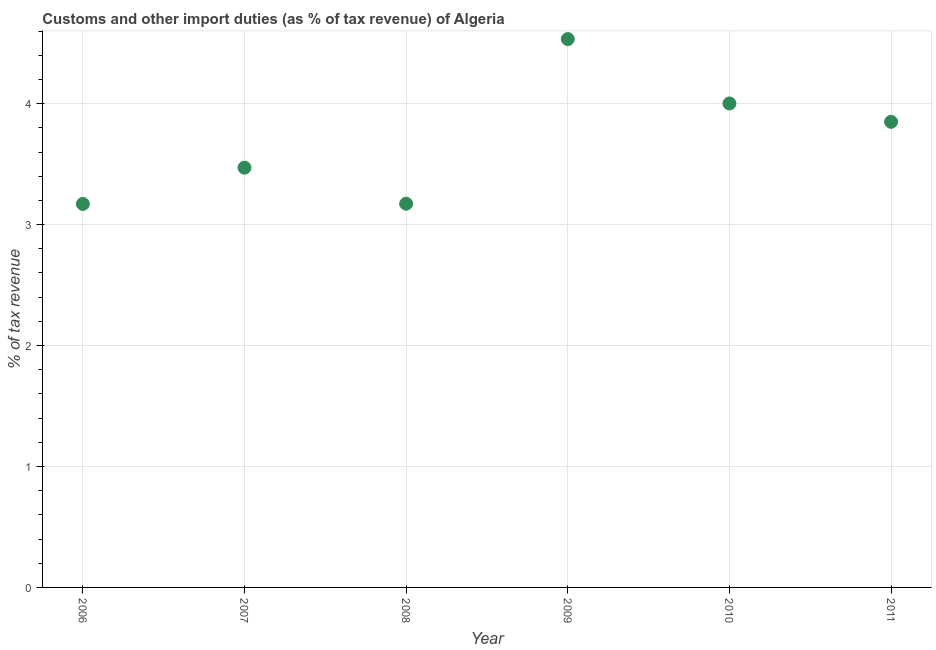What is the customs and other import duties in 2006?
Give a very brief answer. 3.17. Across all years, what is the maximum customs and other import duties?
Make the answer very short. 4.53. Across all years, what is the minimum customs and other import duties?
Keep it short and to the point. 3.17. What is the sum of the customs and other import duties?
Ensure brevity in your answer.  22.2. What is the difference between the customs and other import duties in 2006 and 2010?
Ensure brevity in your answer.  -0.83. What is the average customs and other import duties per year?
Make the answer very short. 3.7. What is the median customs and other import duties?
Your answer should be very brief. 3.66. In how many years, is the customs and other import duties greater than 3.2 %?
Provide a succinct answer. 4. Do a majority of the years between 2007 and 2011 (inclusive) have customs and other import duties greater than 0.6000000000000001 %?
Give a very brief answer. Yes. What is the ratio of the customs and other import duties in 2009 to that in 2011?
Make the answer very short. 1.18. Is the difference between the customs and other import duties in 2009 and 2010 greater than the difference between any two years?
Provide a succinct answer. No. What is the difference between the highest and the second highest customs and other import duties?
Provide a short and direct response. 0.53. What is the difference between the highest and the lowest customs and other import duties?
Keep it short and to the point. 1.36. In how many years, is the customs and other import duties greater than the average customs and other import duties taken over all years?
Keep it short and to the point. 3. How many dotlines are there?
Ensure brevity in your answer.  1. Are the values on the major ticks of Y-axis written in scientific E-notation?
Ensure brevity in your answer.  No. What is the title of the graph?
Provide a short and direct response. Customs and other import duties (as % of tax revenue) of Algeria. What is the label or title of the X-axis?
Make the answer very short. Year. What is the label or title of the Y-axis?
Make the answer very short. % of tax revenue. What is the % of tax revenue in 2006?
Your answer should be very brief. 3.17. What is the % of tax revenue in 2007?
Your response must be concise. 3.47. What is the % of tax revenue in 2008?
Your response must be concise. 3.17. What is the % of tax revenue in 2009?
Your response must be concise. 4.53. What is the % of tax revenue in 2010?
Your answer should be very brief. 4. What is the % of tax revenue in 2011?
Your response must be concise. 3.85. What is the difference between the % of tax revenue in 2006 and 2007?
Ensure brevity in your answer.  -0.3. What is the difference between the % of tax revenue in 2006 and 2008?
Give a very brief answer. -0. What is the difference between the % of tax revenue in 2006 and 2009?
Offer a terse response. -1.36. What is the difference between the % of tax revenue in 2006 and 2010?
Keep it short and to the point. -0.83. What is the difference between the % of tax revenue in 2006 and 2011?
Your response must be concise. -0.68. What is the difference between the % of tax revenue in 2007 and 2008?
Keep it short and to the point. 0.3. What is the difference between the % of tax revenue in 2007 and 2009?
Provide a short and direct response. -1.06. What is the difference between the % of tax revenue in 2007 and 2010?
Provide a succinct answer. -0.53. What is the difference between the % of tax revenue in 2007 and 2011?
Ensure brevity in your answer.  -0.38. What is the difference between the % of tax revenue in 2008 and 2009?
Provide a succinct answer. -1.36. What is the difference between the % of tax revenue in 2008 and 2010?
Offer a very short reply. -0.83. What is the difference between the % of tax revenue in 2008 and 2011?
Give a very brief answer. -0.68. What is the difference between the % of tax revenue in 2009 and 2010?
Your response must be concise. 0.53. What is the difference between the % of tax revenue in 2009 and 2011?
Ensure brevity in your answer.  0.68. What is the difference between the % of tax revenue in 2010 and 2011?
Provide a succinct answer. 0.15. What is the ratio of the % of tax revenue in 2006 to that in 2007?
Keep it short and to the point. 0.91. What is the ratio of the % of tax revenue in 2006 to that in 2008?
Ensure brevity in your answer.  1. What is the ratio of the % of tax revenue in 2006 to that in 2009?
Your answer should be compact. 0.7. What is the ratio of the % of tax revenue in 2006 to that in 2010?
Give a very brief answer. 0.79. What is the ratio of the % of tax revenue in 2006 to that in 2011?
Give a very brief answer. 0.82. What is the ratio of the % of tax revenue in 2007 to that in 2008?
Your answer should be very brief. 1.09. What is the ratio of the % of tax revenue in 2007 to that in 2009?
Your answer should be very brief. 0.77. What is the ratio of the % of tax revenue in 2007 to that in 2010?
Offer a very short reply. 0.87. What is the ratio of the % of tax revenue in 2007 to that in 2011?
Provide a short and direct response. 0.9. What is the ratio of the % of tax revenue in 2008 to that in 2009?
Make the answer very short. 0.7. What is the ratio of the % of tax revenue in 2008 to that in 2010?
Ensure brevity in your answer.  0.79. What is the ratio of the % of tax revenue in 2008 to that in 2011?
Provide a succinct answer. 0.82. What is the ratio of the % of tax revenue in 2009 to that in 2010?
Offer a terse response. 1.13. What is the ratio of the % of tax revenue in 2009 to that in 2011?
Offer a terse response. 1.18. What is the ratio of the % of tax revenue in 2010 to that in 2011?
Offer a very short reply. 1.04. 